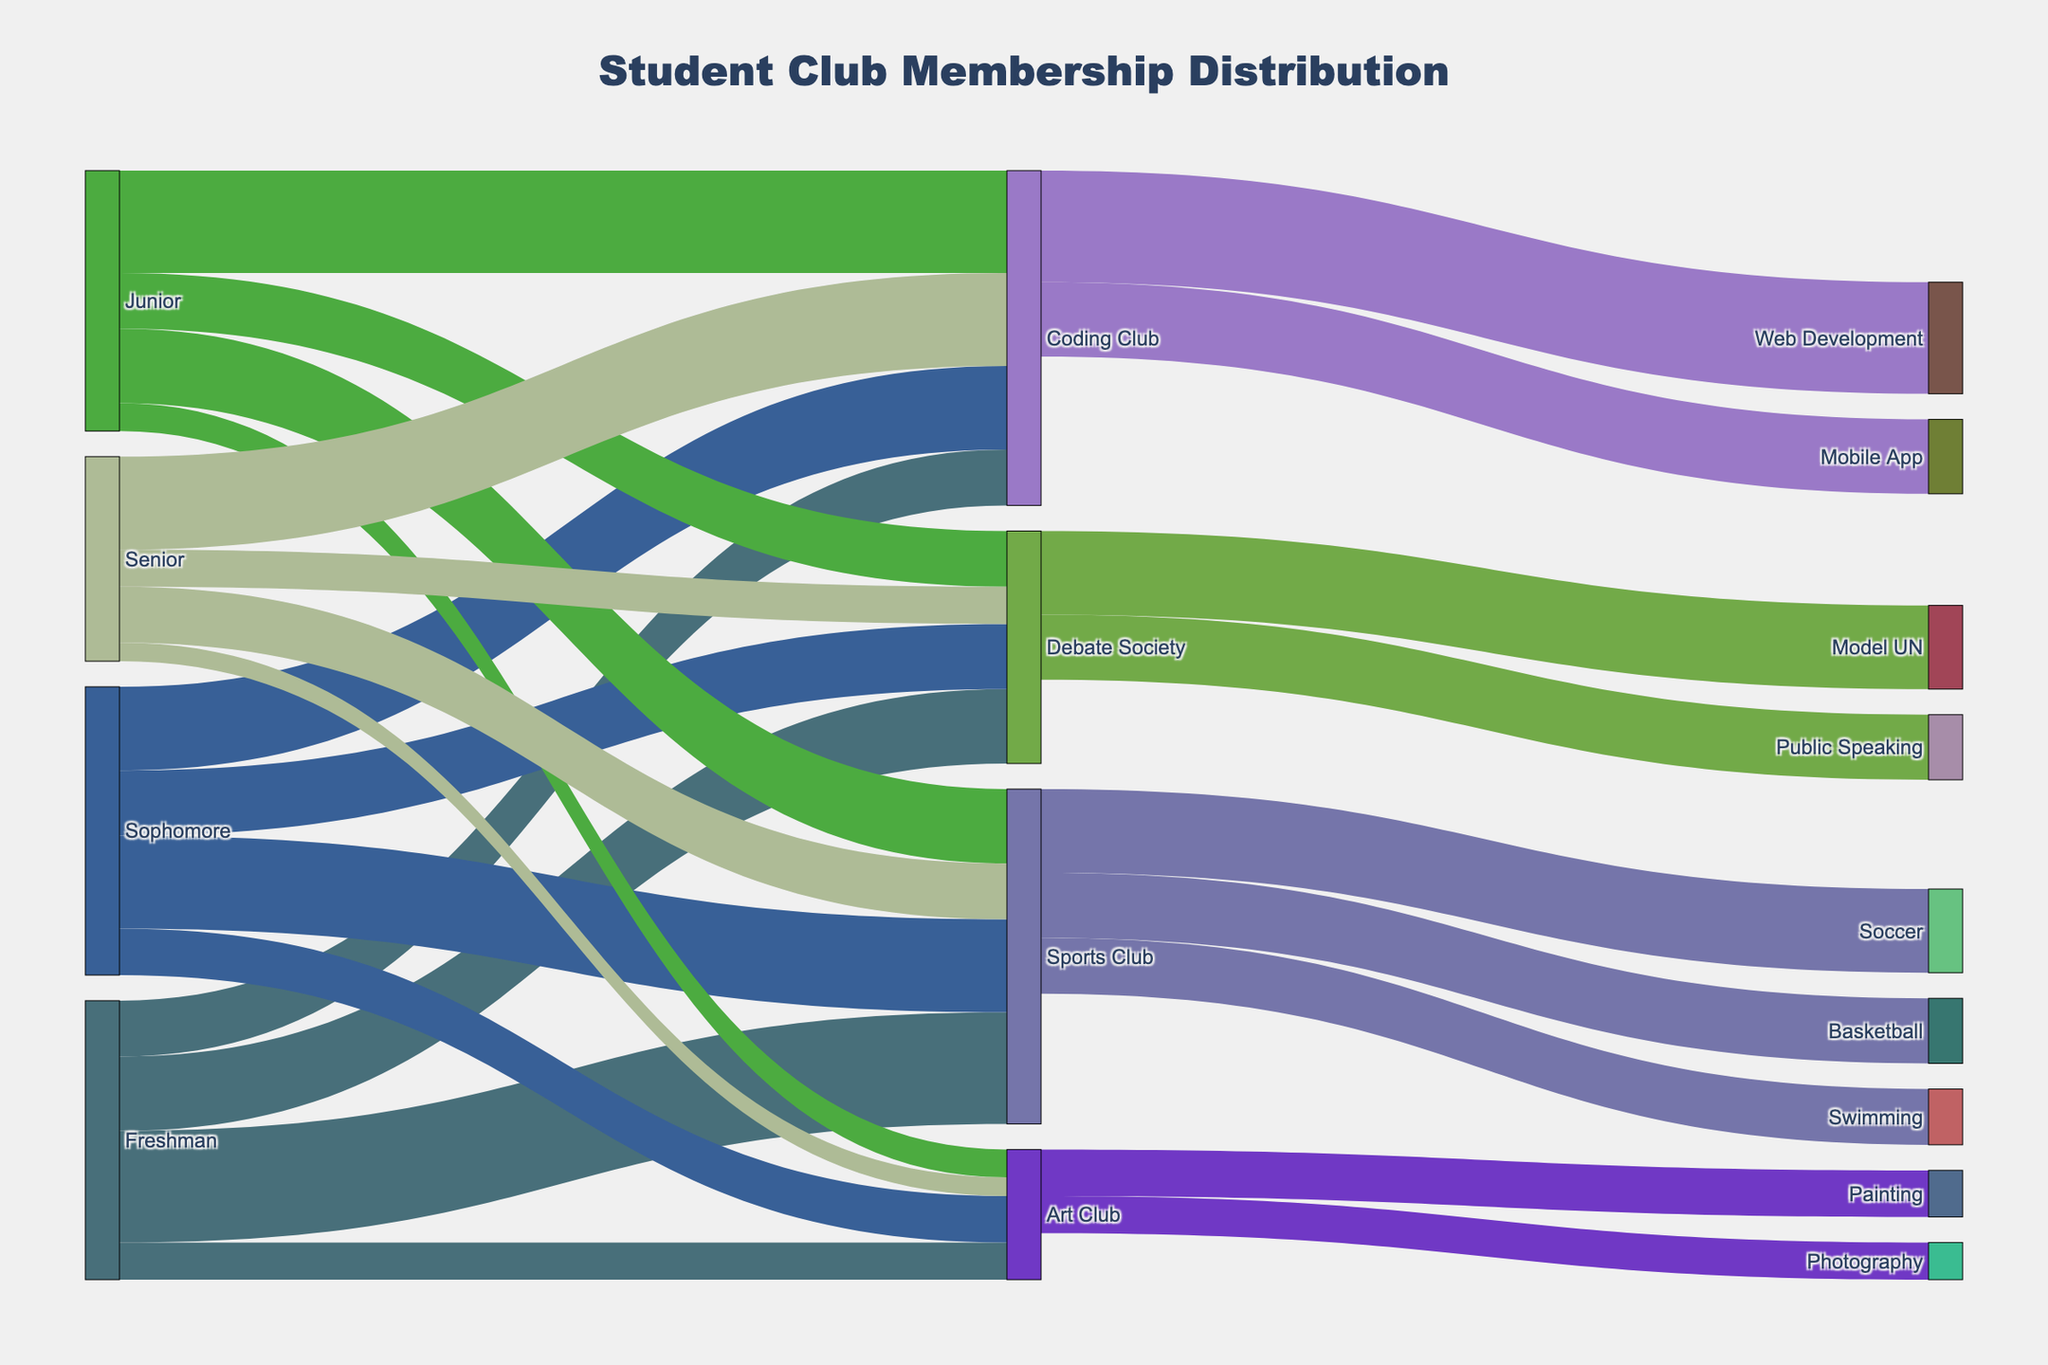How many levels of study are represented in the Sankey diagram? The diagram shows the flow between different levels of study and membership in various clubs. Looking at the nodes on the left, the levels of study are Freshman, Sophomore, Junior, and Senior.
Answer: Four How many students are in the Sports Club in their freshman year? Trace the flow from the Freshman node to the Sports Club node, and observe the value on the link connecting them.
Answer: 120 Which club has the highest number of sophomore members? Look at the links originating from the Sophomore node and compare their values. The club with the highest value is the one with the most members.
Answer: Coding Club What is the total number of members in the Debate Society? Sum the values of the links going into the Debate Society node from all the study levels: 80 (Freshman) + 70 (Sophomore) + 60 (Junior) + 40 (Senior).
Answer: 250 What is the difference in membership between the Coding Club and the Art Club during the junior year? Look at the value on the link connecting Junior to Coding Club and the value on the link connecting Junior to Art Club. Subtract the Art Club value from the Coding Club value: 110 (Coding Club) - 30 (Art Club).
Answer: 80 Which activity within the Sports Club has the most participants? Check the values of the links originating from the Sports Club node to various activities (Basketball, Soccer, Swimming). The activity with the highest value is Soccer.
Answer: Soccer How does the membership in the Coding Club change from Freshman to Senior year? Observe the values of the links connecting each year to the Coding Club node: 60 (Freshman), 90 (Sophomore), 110 (Junior), and 100 (Senior). The membership increases significantly from Freshman (60) to Junior (110) then slightly decreases to Senior (100).
Answer: It increases then slightly decreases Which club has a higher total membership in the senior year: Sports Club or Debate Society? Look at the links originating from the Senior node to both Sports Club and Debate Society. Compare their values: 60 (Sports Club) vs. 40 (Debate Society).
Answer: Sports Club What is the total number of students involved in the Art Club across all years? Sum the values of the links going to the Art Club node from all study levels (Freshman, Sophomore, Junior, Senior): 40 (Freshman) + 50 (Sophomore) + 30 (Junior) + 20 (Senior).
Answer: 140 Which activity within the Art Club has more members? Compare the values of the links originating from the Art Club node to both Painting and Photography. The one with the higher value is Painting.
Answer: Painting 